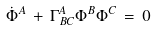<formula> <loc_0><loc_0><loc_500><loc_500>\dot { \Phi } ^ { A } \, + \, \Gamma ^ { A } _ { B C } \Phi ^ { B } \Phi ^ { C } \, = \, 0</formula> 